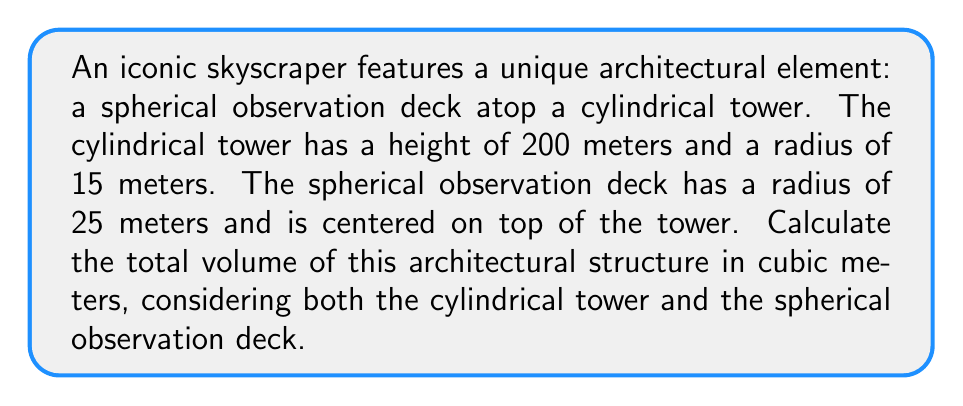Give your solution to this math problem. To solve this problem, we need to calculate the volumes of both the cylindrical tower and the spherical observation deck, then add them together. Let's break it down step-by-step:

1. Calculate the volume of the cylindrical tower:
   The formula for the volume of a cylinder is $V_c = \pi r^2 h$
   where $r$ is the radius and $h$ is the height.

   $V_c = \pi \cdot (15\text{ m})^2 \cdot 200\text{ m}$
   $V_c = \pi \cdot 225\text{ m}^2 \cdot 200\text{ m}$
   $V_c = 141,371.67\text{ m}^3$

2. Calculate the volume of the spherical observation deck:
   The formula for the volume of a sphere is $V_s = \frac{4}{3}\pi r^3$
   where $r$ is the radius.

   $V_s = \frac{4}{3}\pi \cdot (25\text{ m})^3$
   $V_s = \frac{4}{3}\pi \cdot 15,625\text{ m}^3$
   $V_s = 65,449.85\text{ m}^3$

3. Sum up the volumes to get the total volume:
   $V_{total} = V_c + V_s$
   $V_{total} = 141,371.67\text{ m}^3 + 65,449.85\text{ m}^3$
   $V_{total} = 206,821.52\text{ m}^3$

Therefore, the total volume of the architectural structure is approximately 206,821.52 cubic meters.
Answer: 206,821.52 m³ 